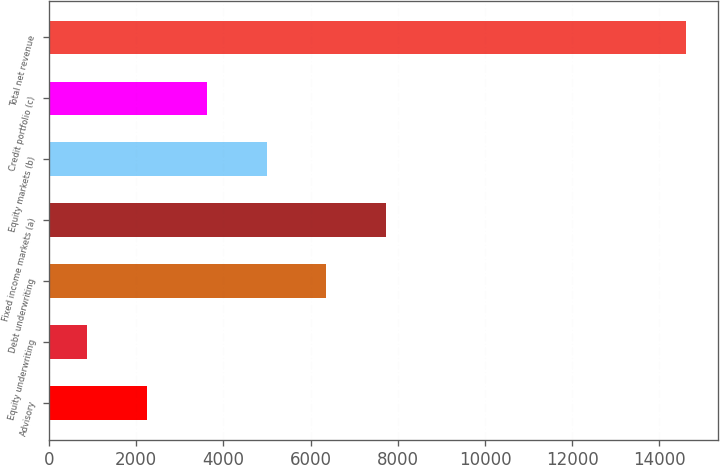Convert chart. <chart><loc_0><loc_0><loc_500><loc_500><bar_chart><fcel>Advisory<fcel>Equity underwriting<fcel>Debt underwriting<fcel>Fixed income markets (a)<fcel>Equity markets (b)<fcel>Credit portfolio (c)<fcel>Total net revenue<nl><fcel>2238.9<fcel>864<fcel>6363.6<fcel>7738.5<fcel>4988.7<fcel>3613.8<fcel>14613<nl></chart> 